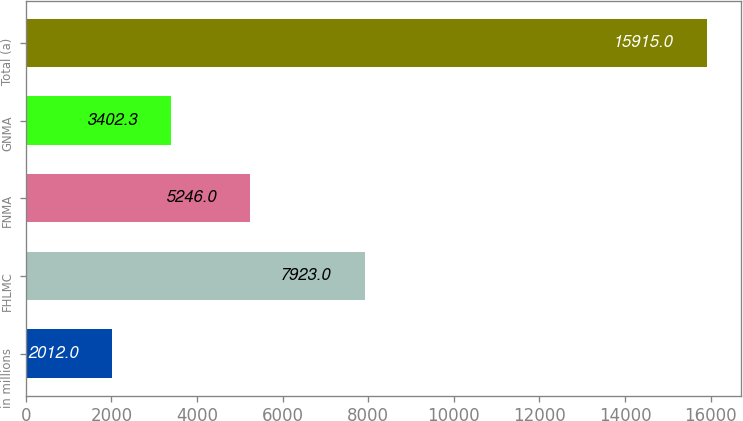<chart> <loc_0><loc_0><loc_500><loc_500><bar_chart><fcel>in millions<fcel>FHLMC<fcel>FNMA<fcel>GNMA<fcel>Total (a)<nl><fcel>2012<fcel>7923<fcel>5246<fcel>3402.3<fcel>15915<nl></chart> 